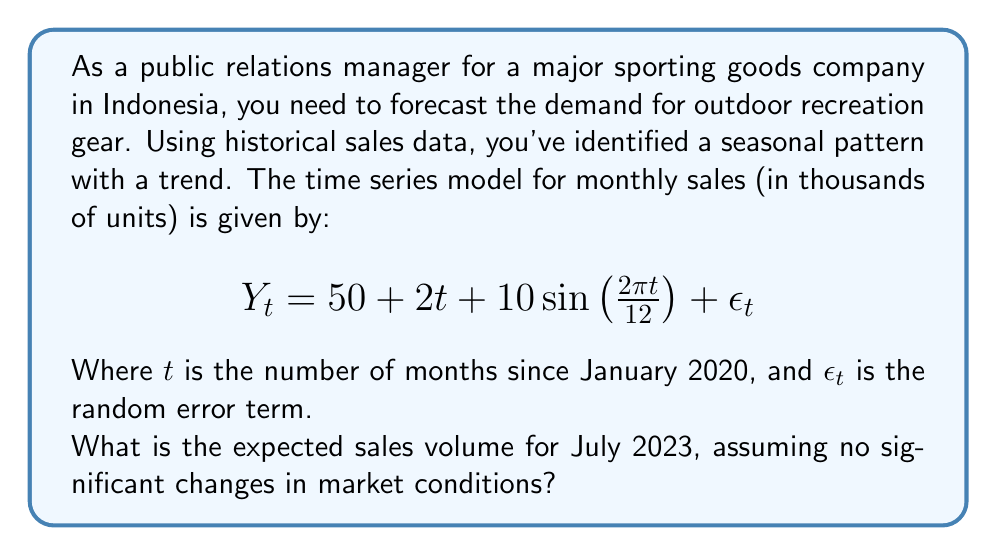Can you answer this question? To solve this problem, we need to follow these steps:

1. Identify the components of the time series model:
   - Intercept: 50
   - Trend: $2t$
   - Seasonal component: $10\sin\left(\frac{2\pi t}{12}\right)$
   - Error term: $\epsilon_t$ (assumed to be zero for forecasting)

2. Calculate the value of $t$ for July 2023:
   - January 2020 is $t = 0$
   - July 2023 is 42 months later, so $t = 42$

3. Substitute $t = 42$ into the model equation:

   $$Y_{42} = 50 + 2(42) + 10\sin\left(\frac{2\pi (42)}{12}\right)$$

4. Simplify the trend component:
   $50 + 2(42) = 50 + 84 = 134$

5. Simplify the seasonal component:
   $10\sin\left(\frac{2\pi (42)}{12}\right) = 10\sin(7\pi) = 0$

6. Sum up all components:
   $Y_{42} = 134 + 0 = 134$

Therefore, the expected sales volume for July 2023 is 134 thousand units.
Answer: 134 thousand units 